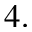Convert formula to latex. <formula><loc_0><loc_0><loc_500><loc_500>4 .</formula> 